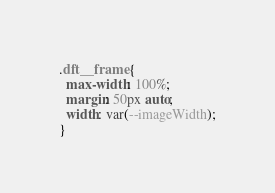<code> <loc_0><loc_0><loc_500><loc_500><_CSS_>.dft__frame {
  max-width: 100%;
  margin: 50px auto;
  width: var(--imageWidth);
}
</code> 